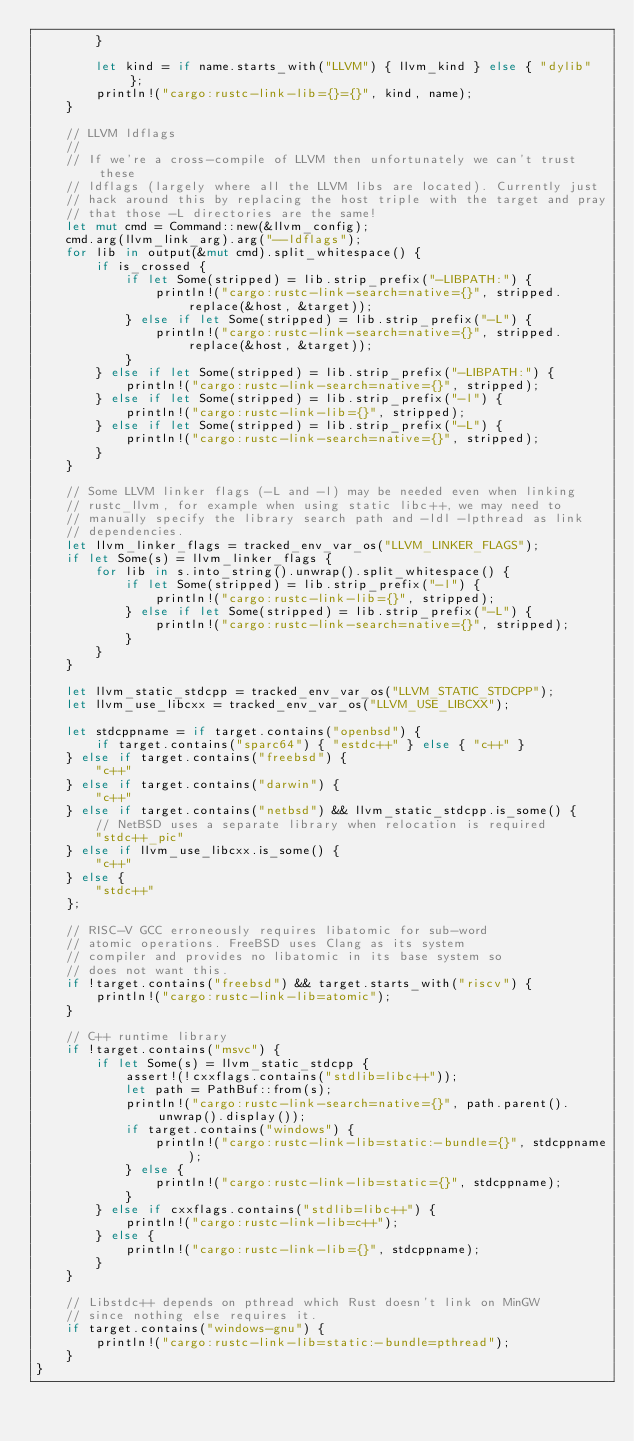<code> <loc_0><loc_0><loc_500><loc_500><_Rust_>        }

        let kind = if name.starts_with("LLVM") { llvm_kind } else { "dylib" };
        println!("cargo:rustc-link-lib={}={}", kind, name);
    }

    // LLVM ldflags
    //
    // If we're a cross-compile of LLVM then unfortunately we can't trust these
    // ldflags (largely where all the LLVM libs are located). Currently just
    // hack around this by replacing the host triple with the target and pray
    // that those -L directories are the same!
    let mut cmd = Command::new(&llvm_config);
    cmd.arg(llvm_link_arg).arg("--ldflags");
    for lib in output(&mut cmd).split_whitespace() {
        if is_crossed {
            if let Some(stripped) = lib.strip_prefix("-LIBPATH:") {
                println!("cargo:rustc-link-search=native={}", stripped.replace(&host, &target));
            } else if let Some(stripped) = lib.strip_prefix("-L") {
                println!("cargo:rustc-link-search=native={}", stripped.replace(&host, &target));
            }
        } else if let Some(stripped) = lib.strip_prefix("-LIBPATH:") {
            println!("cargo:rustc-link-search=native={}", stripped);
        } else if let Some(stripped) = lib.strip_prefix("-l") {
            println!("cargo:rustc-link-lib={}", stripped);
        } else if let Some(stripped) = lib.strip_prefix("-L") {
            println!("cargo:rustc-link-search=native={}", stripped);
        }
    }

    // Some LLVM linker flags (-L and -l) may be needed even when linking
    // rustc_llvm, for example when using static libc++, we may need to
    // manually specify the library search path and -ldl -lpthread as link
    // dependencies.
    let llvm_linker_flags = tracked_env_var_os("LLVM_LINKER_FLAGS");
    if let Some(s) = llvm_linker_flags {
        for lib in s.into_string().unwrap().split_whitespace() {
            if let Some(stripped) = lib.strip_prefix("-l") {
                println!("cargo:rustc-link-lib={}", stripped);
            } else if let Some(stripped) = lib.strip_prefix("-L") {
                println!("cargo:rustc-link-search=native={}", stripped);
            }
        }
    }

    let llvm_static_stdcpp = tracked_env_var_os("LLVM_STATIC_STDCPP");
    let llvm_use_libcxx = tracked_env_var_os("LLVM_USE_LIBCXX");

    let stdcppname = if target.contains("openbsd") {
        if target.contains("sparc64") { "estdc++" } else { "c++" }
    } else if target.contains("freebsd") {
        "c++"
    } else if target.contains("darwin") {
        "c++"
    } else if target.contains("netbsd") && llvm_static_stdcpp.is_some() {
        // NetBSD uses a separate library when relocation is required
        "stdc++_pic"
    } else if llvm_use_libcxx.is_some() {
        "c++"
    } else {
        "stdc++"
    };

    // RISC-V GCC erroneously requires libatomic for sub-word
    // atomic operations. FreeBSD uses Clang as its system
    // compiler and provides no libatomic in its base system so
    // does not want this.
    if !target.contains("freebsd") && target.starts_with("riscv") {
        println!("cargo:rustc-link-lib=atomic");
    }

    // C++ runtime library
    if !target.contains("msvc") {
        if let Some(s) = llvm_static_stdcpp {
            assert!(!cxxflags.contains("stdlib=libc++"));
            let path = PathBuf::from(s);
            println!("cargo:rustc-link-search=native={}", path.parent().unwrap().display());
            if target.contains("windows") {
                println!("cargo:rustc-link-lib=static:-bundle={}", stdcppname);
            } else {
                println!("cargo:rustc-link-lib=static={}", stdcppname);
            }
        } else if cxxflags.contains("stdlib=libc++") {
            println!("cargo:rustc-link-lib=c++");
        } else {
            println!("cargo:rustc-link-lib={}", stdcppname);
        }
    }

    // Libstdc++ depends on pthread which Rust doesn't link on MinGW
    // since nothing else requires it.
    if target.contains("windows-gnu") {
        println!("cargo:rustc-link-lib=static:-bundle=pthread");
    }
}
</code> 